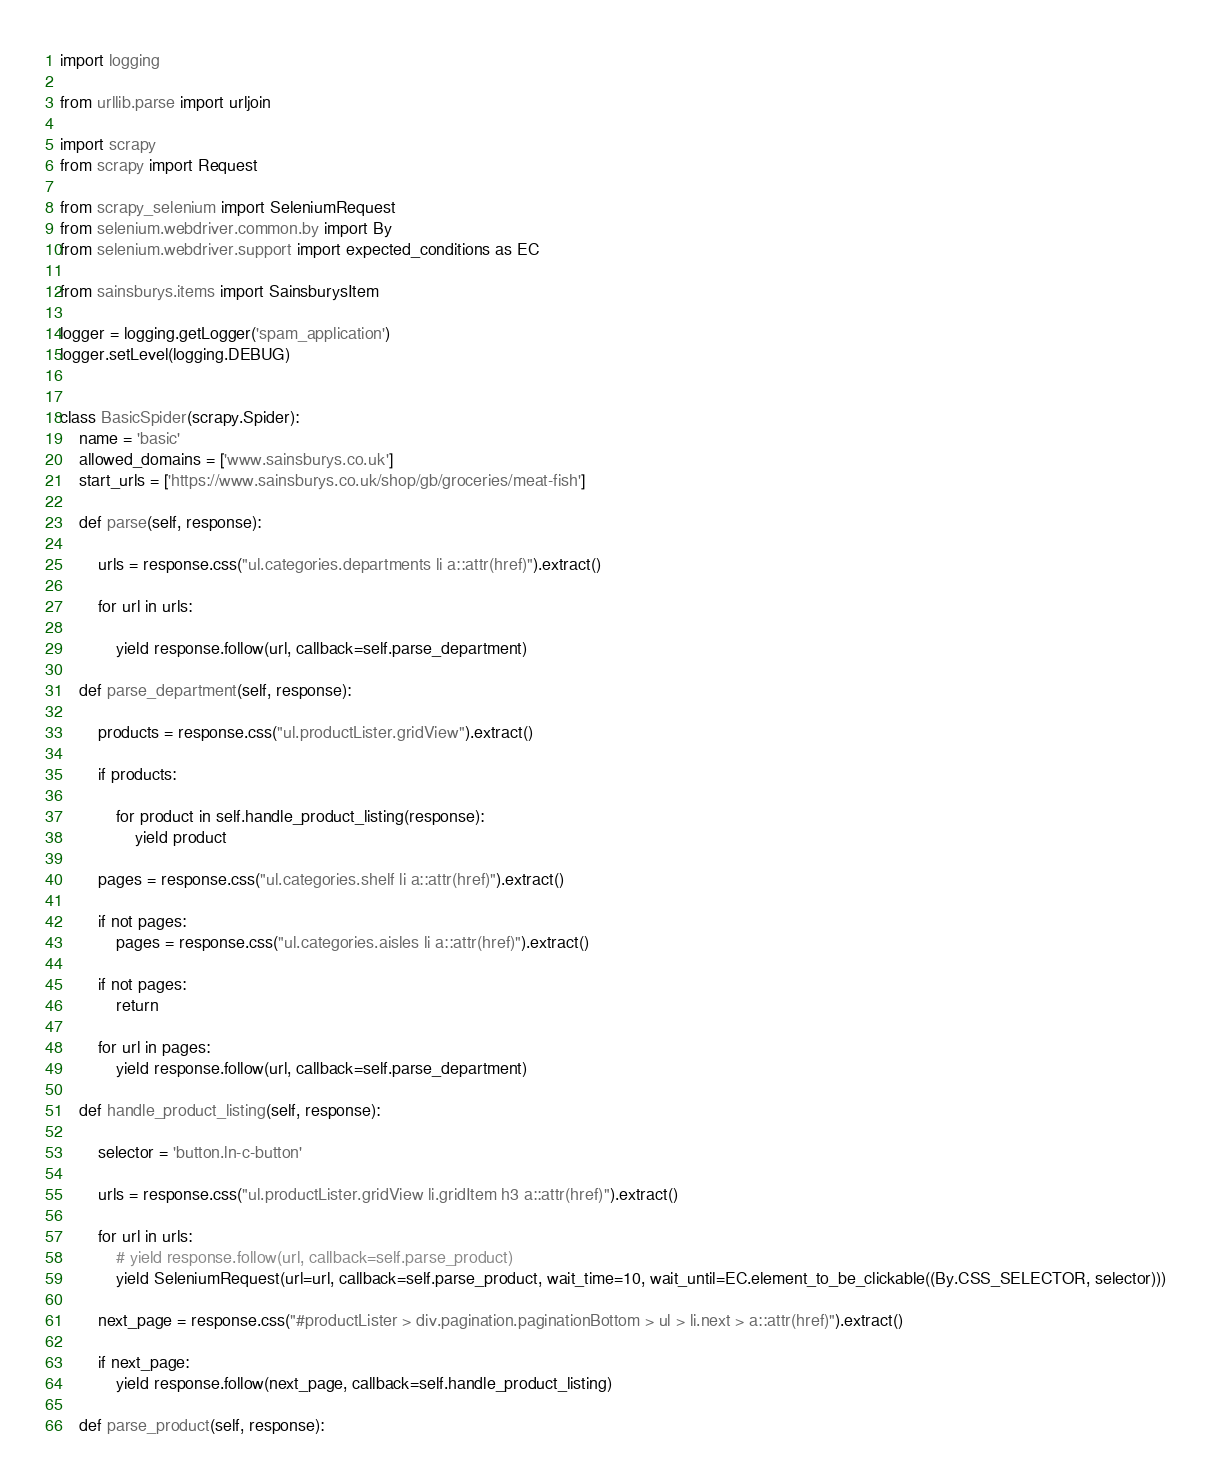<code> <loc_0><loc_0><loc_500><loc_500><_Python_>import logging

from urllib.parse import urljoin

import scrapy
from scrapy import Request

from scrapy_selenium import SeleniumRequest
from selenium.webdriver.common.by import By
from selenium.webdriver.support import expected_conditions as EC

from sainsburys.items import SainsburysItem

logger = logging.getLogger('spam_application')
logger.setLevel(logging.DEBUG)


class BasicSpider(scrapy.Spider):
    name = 'basic'
    allowed_domains = ['www.sainsburys.co.uk']
    start_urls = ['https://www.sainsburys.co.uk/shop/gb/groceries/meat-fish']

    def parse(self, response):
        
        urls = response.css("ul.categories.departments li a::attr(href)").extract()

        for url in urls:
            
            yield response.follow(url, callback=self.parse_department)

    def parse_department(self, response):

        products = response.css("ul.productLister.gridView").extract()

        if products:

            for product in self.handle_product_listing(response):
                yield product
        
        pages = response.css("ul.categories.shelf li a::attr(href)").extract()

        if not pages:
            pages = response.css("ul.categories.aisles li a::attr(href)").extract()

        if not pages:
            return
        
        for url in pages:
            yield response.follow(url, callback=self.parse_department)

    def handle_product_listing(self, response):

        selector = 'button.ln-c-button'

        urls = response.css("ul.productLister.gridView li.gridItem h3 a::attr(href)").extract()

        for url in urls:
            # yield response.follow(url, callback=self.parse_product)
            yield SeleniumRequest(url=url, callback=self.parse_product, wait_time=10, wait_until=EC.element_to_be_clickable((By.CSS_SELECTOR, selector)))

        next_page = response.css("#productLister > div.pagination.paginationBottom > ul > li.next > a::attr(href)").extract()

        if next_page:
            yield response.follow(next_page, callback=self.handle_product_listing)

    def parse_product(self, response):
</code> 